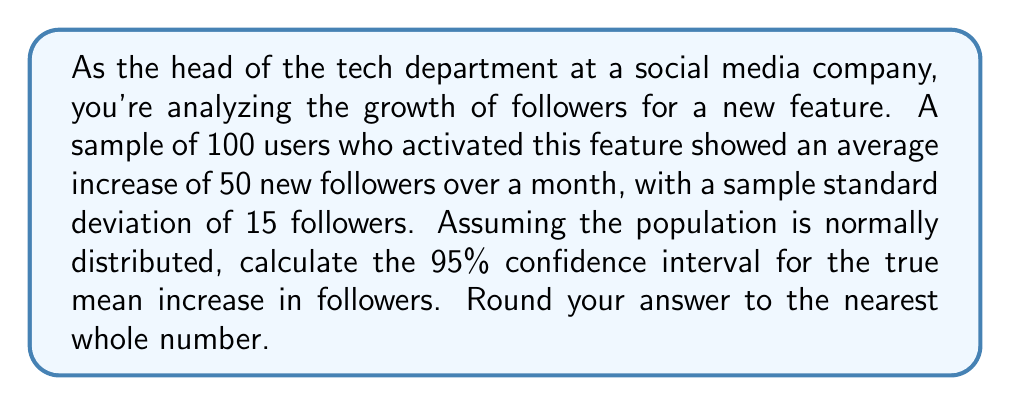Provide a solution to this math problem. To calculate the confidence interval, we'll use the formula:

$$\text{CI} = \bar{x} \pm t_{\alpha/2} \cdot \frac{s}{\sqrt{n}}$$

Where:
$\bar{x}$ = sample mean = 50
$s$ = sample standard deviation = 15
$n$ = sample size = 100
$t_{\alpha/2}$ = t-value for 95% confidence interval with 99 degrees of freedom

Steps:
1) For a 95% CI with 99 degrees of freedom, $t_{\alpha/2} \approx 1.984$ (from t-distribution table)

2) Calculate the margin of error:
   $$\text{ME} = t_{\alpha/2} \cdot \frac{s}{\sqrt{n}} = 1.984 \cdot \frac{15}{\sqrt{100}} = 1.984 \cdot 1.5 = 2.976$$

3) Calculate the confidence interval:
   $$\text{CI} = 50 \pm 2.976$$
   $$\text{Lower bound} = 50 - 2.976 = 47.024$$
   $$\text{Upper bound} = 50 + 2.976 = 52.976$$

4) Rounding to the nearest whole number:
   Lower bound: 47
   Upper bound: 53
Answer: The 95% confidence interval for the true mean increase in followers is (47, 53). 